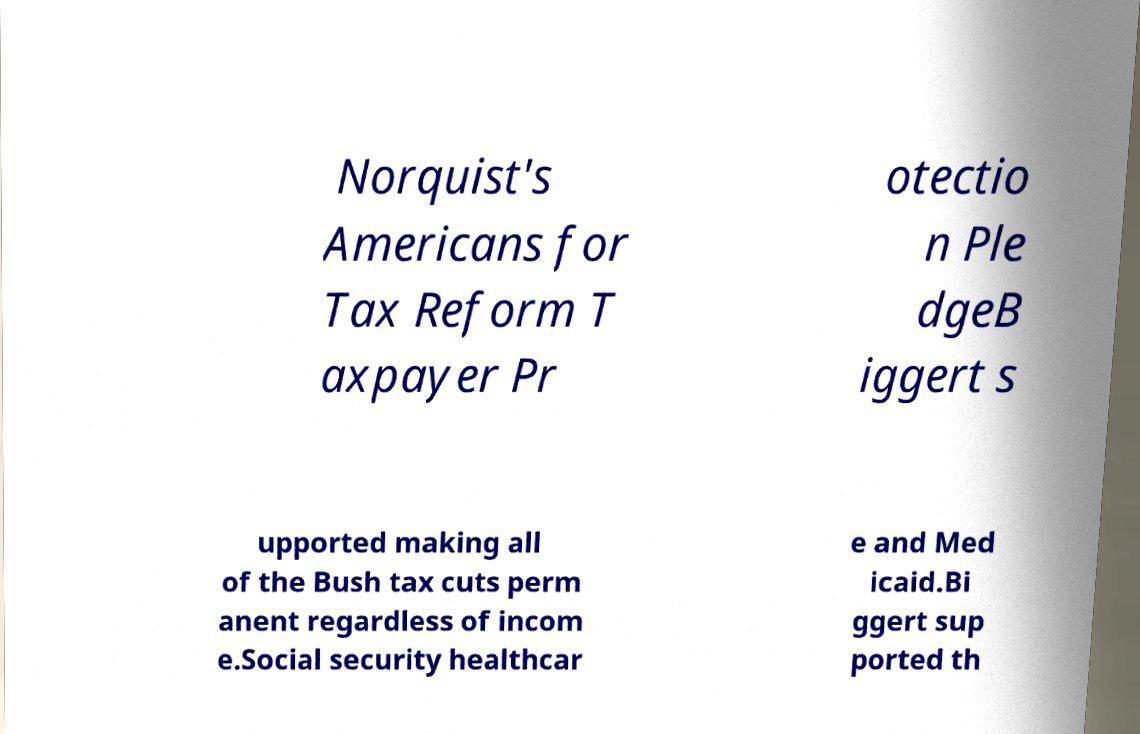Could you extract and type out the text from this image? Norquist's Americans for Tax Reform T axpayer Pr otectio n Ple dgeB iggert s upported making all of the Bush tax cuts perm anent regardless of incom e.Social security healthcar e and Med icaid.Bi ggert sup ported th 